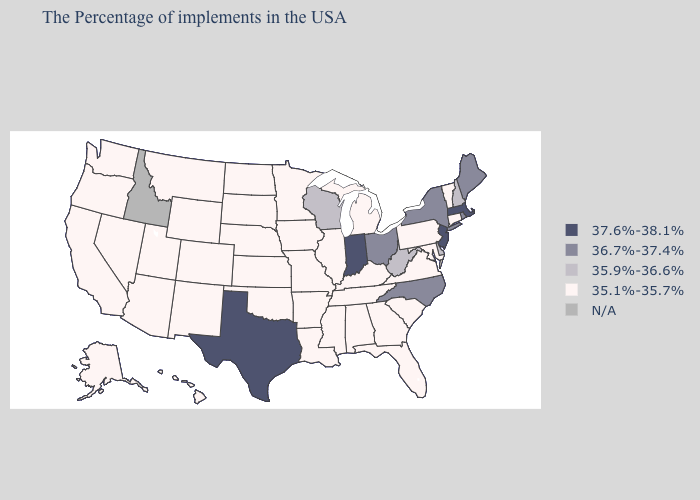Does Minnesota have the lowest value in the USA?
Quick response, please. Yes. Name the states that have a value in the range 37.6%-38.1%?
Quick response, please. Massachusetts, New Jersey, Indiana, Texas. What is the value of Wisconsin?
Write a very short answer. 35.9%-36.6%. Among the states that border Delaware , does Maryland have the highest value?
Answer briefly. No. Is the legend a continuous bar?
Keep it brief. No. What is the highest value in states that border Oregon?
Keep it brief. 35.1%-35.7%. What is the value of South Carolina?
Concise answer only. 35.1%-35.7%. Among the states that border Vermont , does New York have the lowest value?
Write a very short answer. No. What is the value of Connecticut?
Give a very brief answer. 35.1%-35.7%. What is the value of Massachusetts?
Write a very short answer. 37.6%-38.1%. What is the highest value in the USA?
Be succinct. 37.6%-38.1%. What is the value of Maryland?
Quick response, please. 35.1%-35.7%. 